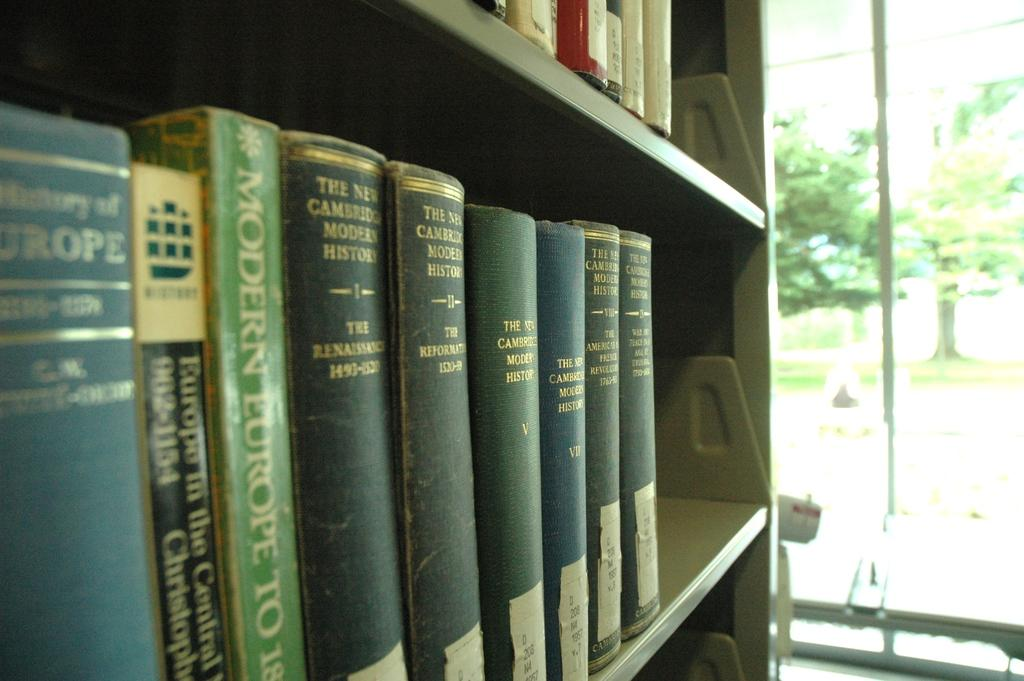<image>
Give a short and clear explanation of the subsequent image. Several books on modern history hit on a shelf in a library. 